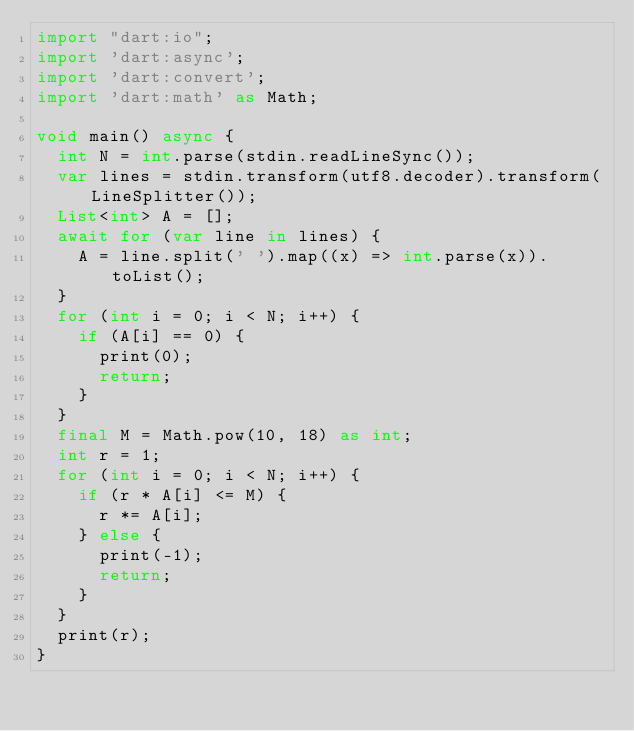Convert code to text. <code><loc_0><loc_0><loc_500><loc_500><_Dart_>import "dart:io";
import 'dart:async';
import 'dart:convert';
import 'dart:math' as Math;

void main() async {
  int N = int.parse(stdin.readLineSync());
  var lines = stdin.transform(utf8.decoder).transform(LineSplitter());
  List<int> A = [];
  await for (var line in lines) {
    A = line.split(' ').map((x) => int.parse(x)).toList();
  }
  for (int i = 0; i < N; i++) {
    if (A[i] == 0) {
      print(0);
      return;
    }
  }
  final M = Math.pow(10, 18) as int;
  int r = 1;
  for (int i = 0; i < N; i++) {
    if (r * A[i] <= M) {
      r *= A[i];
    } else {
      print(-1);
      return;
    }
  }
  print(r);
}
</code> 